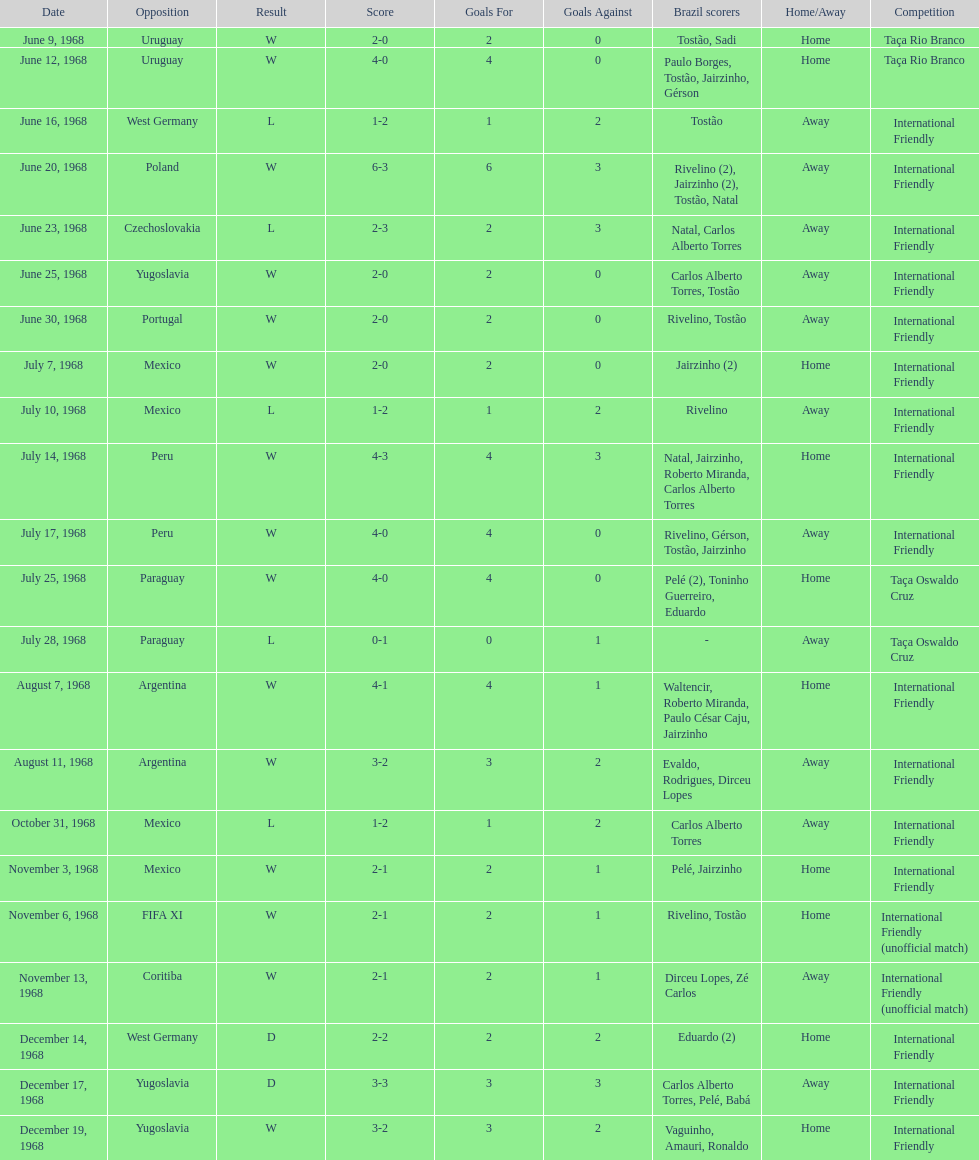Name the first competition ever played by brazil. Taça Rio Branco. 